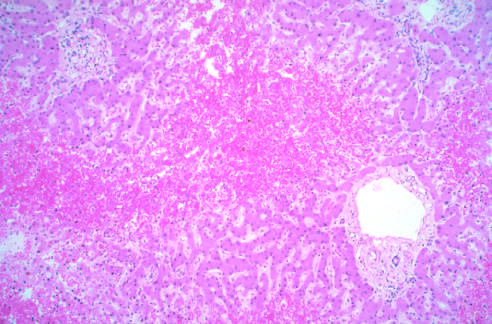what are not easily seen?
Answer the question using a single word or phrase. Atrophied hepatocytes 